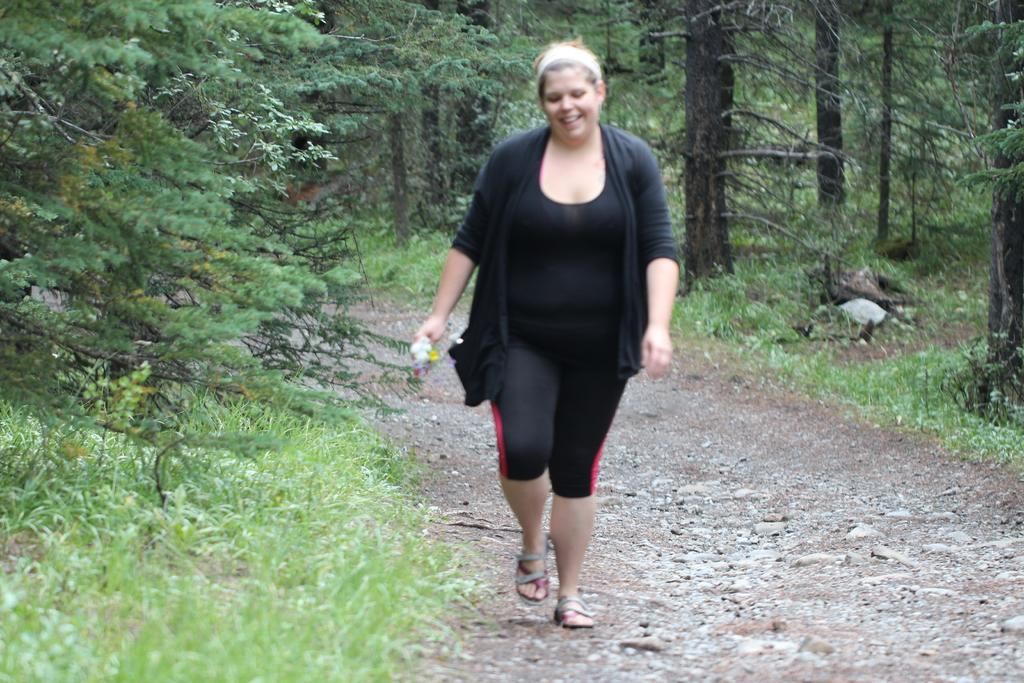Who is present in the image? There is a woman in the image. What is the woman doing in the image? The woman is walking in the image. What is the woman holding in the image? The woman is holding an object in the image. What type of terrain can be seen in the image? There is grass visible in the image. What can be seen in the background of the image? There are trees in the background of the image. What type of marble is the woman using to play a game in the image? There is no marble present in the image, and the woman is not playing a game. 